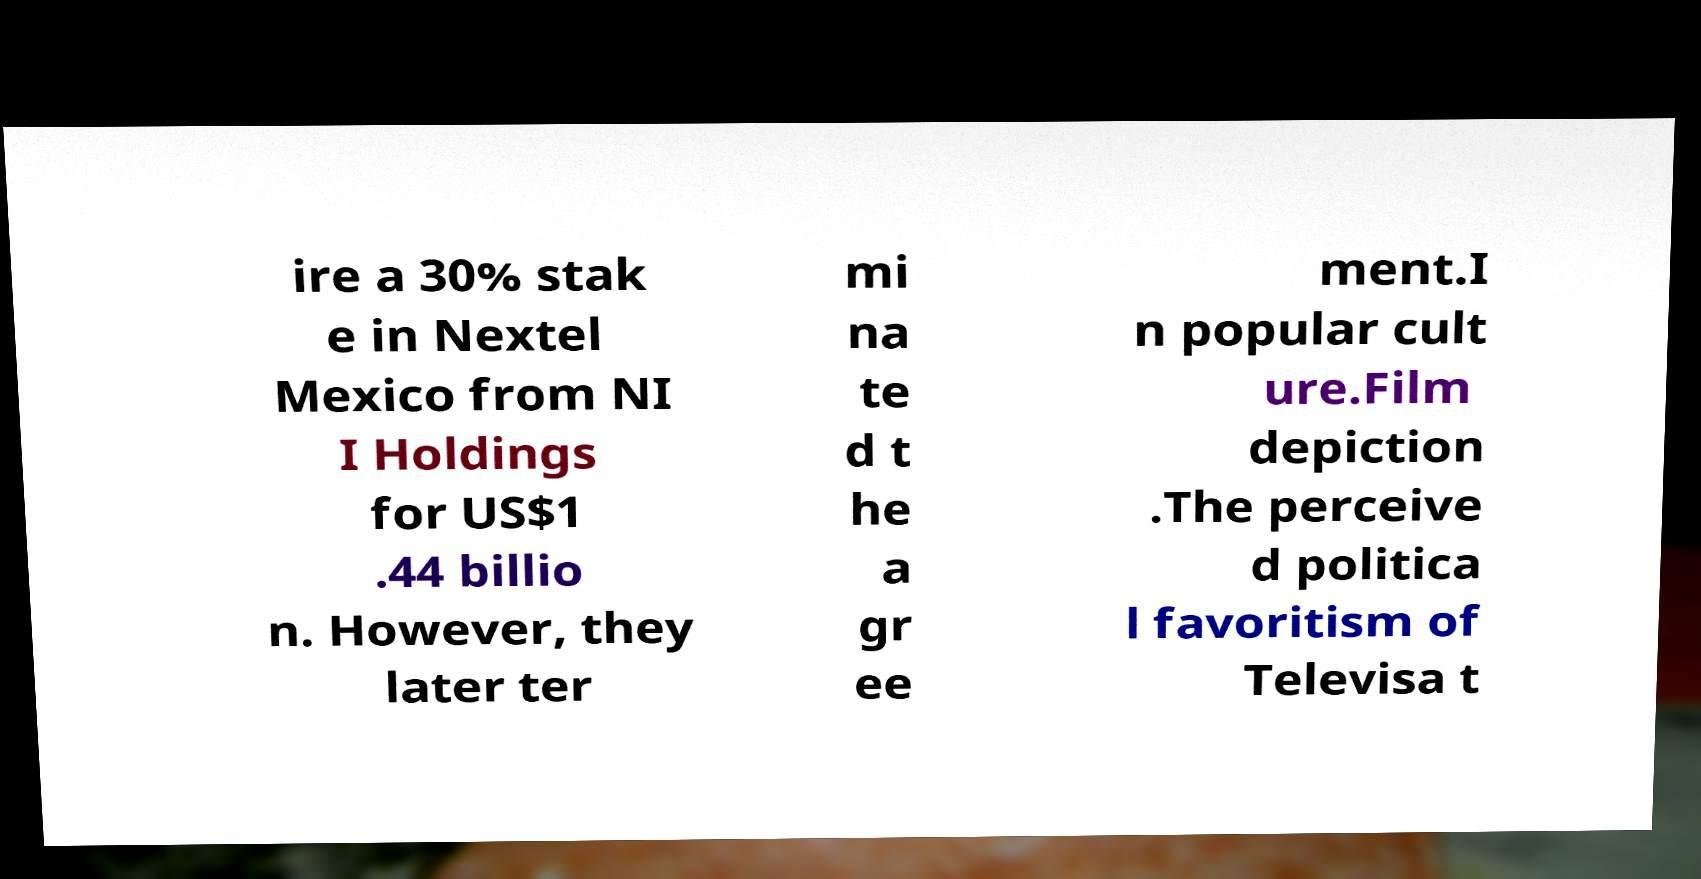There's text embedded in this image that I need extracted. Can you transcribe it verbatim? ire a 30% stak e in Nextel Mexico from NI I Holdings for US$1 .44 billio n. However, they later ter mi na te d t he a gr ee ment.I n popular cult ure.Film depiction .The perceive d politica l favoritism of Televisa t 